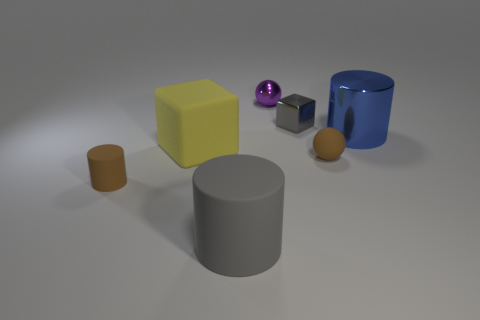Subtract all gray cylinders. How many cylinders are left? 2 Add 2 blue blocks. How many objects exist? 9 Subtract all brown cylinders. How many cylinders are left? 2 Subtract 2 cubes. How many cubes are left? 0 Subtract all cylinders. How many objects are left? 4 Subtract all red cylinders. Subtract all blue spheres. How many cylinders are left? 3 Subtract all brown cylinders. Subtract all small metal cubes. How many objects are left? 5 Add 1 small gray blocks. How many small gray blocks are left? 2 Add 7 large matte spheres. How many large matte spheres exist? 7 Subtract 0 cyan blocks. How many objects are left? 7 